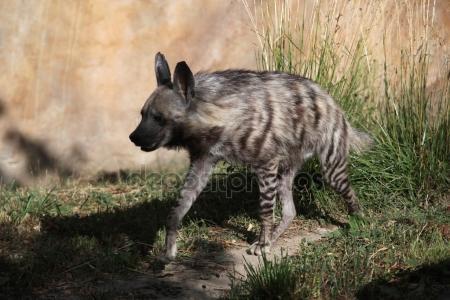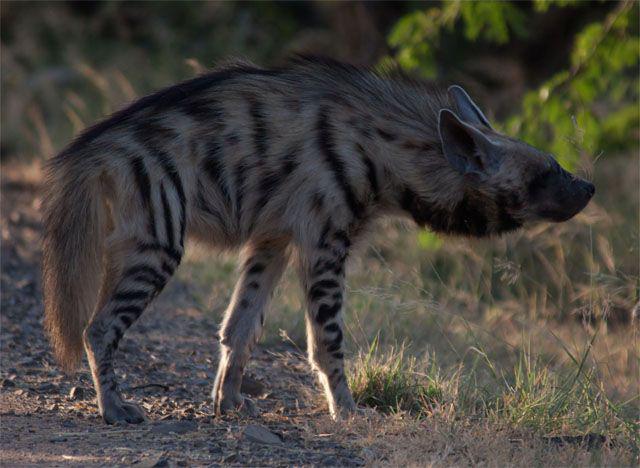The first image is the image on the left, the second image is the image on the right. Examine the images to the left and right. Is the description "Right image shows a hyena with nothing in its mouth." accurate? Answer yes or no. Yes. The first image is the image on the left, the second image is the image on the right. Examine the images to the left and right. Is the description "1 hyena with no prey in its mouth is walking toward the left." accurate? Answer yes or no. Yes. 